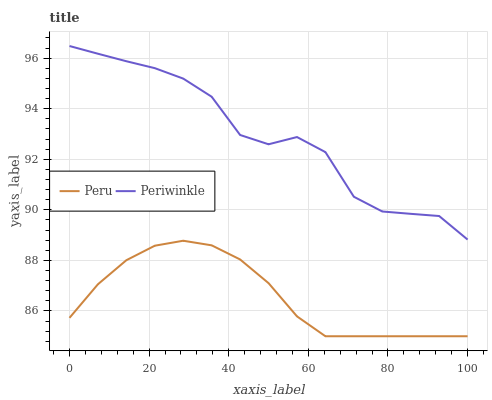Does Peru have the minimum area under the curve?
Answer yes or no. Yes. Does Periwinkle have the maximum area under the curve?
Answer yes or no. Yes. Does Peru have the maximum area under the curve?
Answer yes or no. No. Is Peru the smoothest?
Answer yes or no. Yes. Is Periwinkle the roughest?
Answer yes or no. Yes. Is Peru the roughest?
Answer yes or no. No. Does Peru have the highest value?
Answer yes or no. No. Is Peru less than Periwinkle?
Answer yes or no. Yes. Is Periwinkle greater than Peru?
Answer yes or no. Yes. Does Peru intersect Periwinkle?
Answer yes or no. No. 